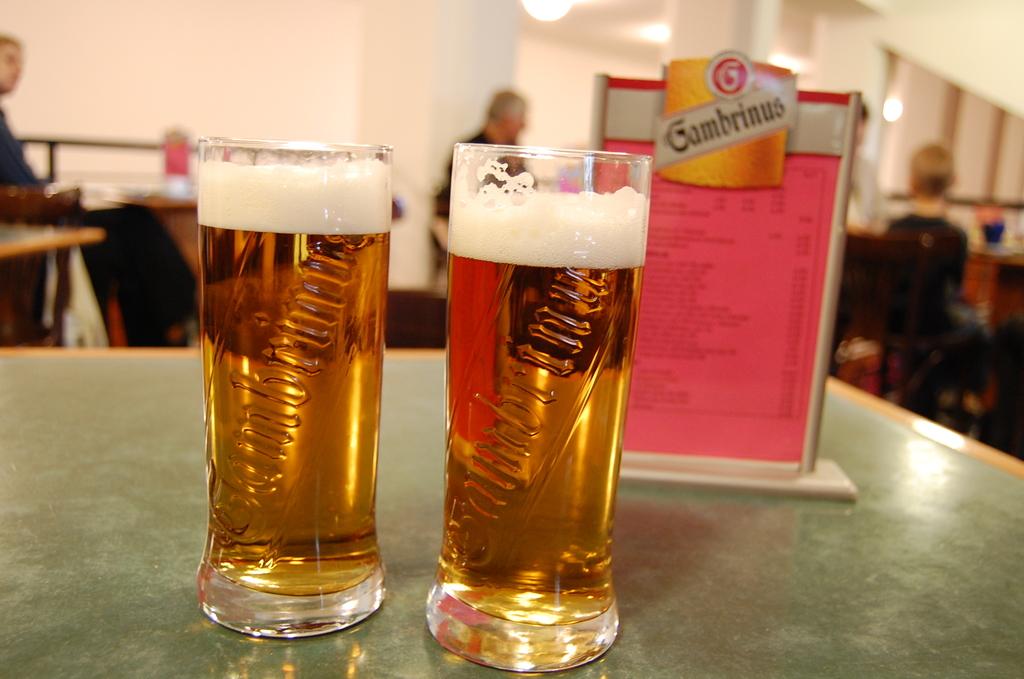What beer is that?
Provide a short and direct response. Gambrinus. 